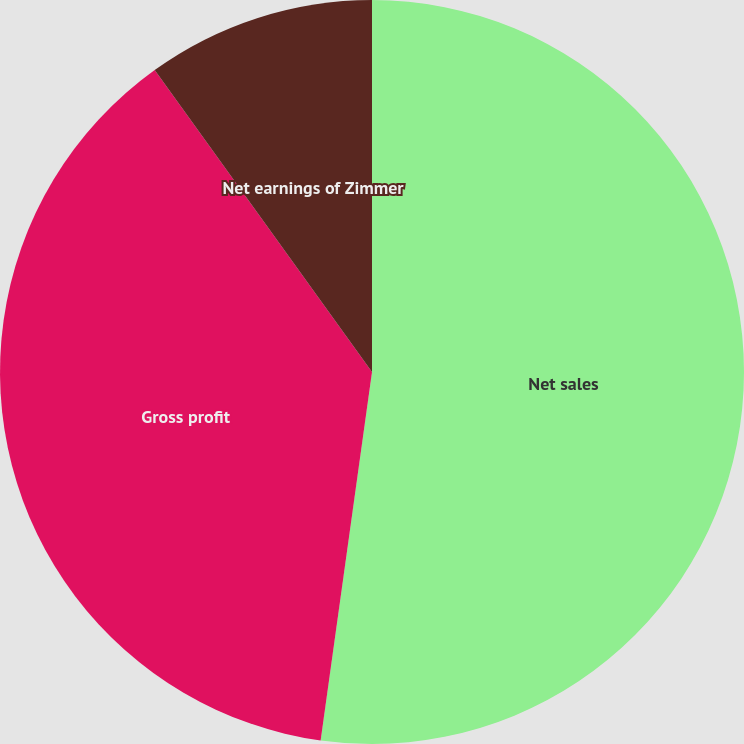Convert chart. <chart><loc_0><loc_0><loc_500><loc_500><pie_chart><fcel>Net sales<fcel>Gross profit<fcel>Net earnings of Zimmer<nl><fcel>52.21%<fcel>37.87%<fcel>9.93%<nl></chart> 